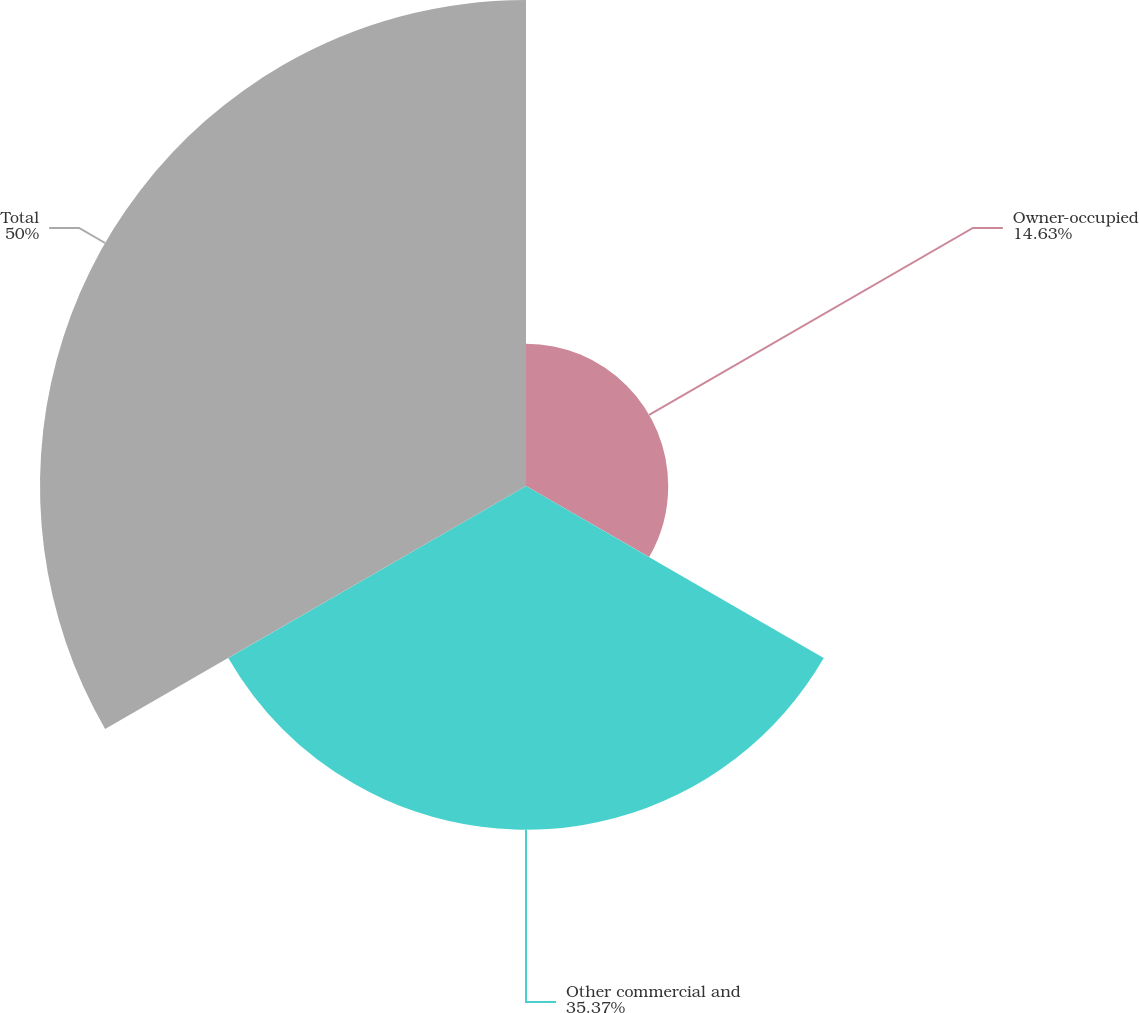Convert chart. <chart><loc_0><loc_0><loc_500><loc_500><pie_chart><fcel>Owner-occupied<fcel>Other commercial and<fcel>Total<nl><fcel>14.63%<fcel>35.37%<fcel>50.0%<nl></chart> 